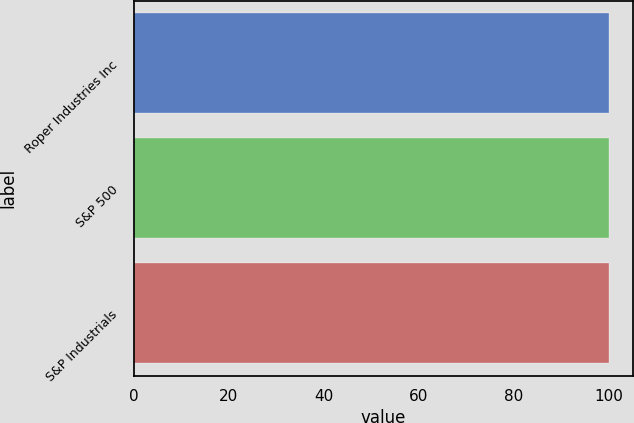<chart> <loc_0><loc_0><loc_500><loc_500><bar_chart><fcel>Roper Industries Inc<fcel>S&P 500<fcel>S&P Industrials<nl><fcel>100<fcel>100.1<fcel>100.2<nl></chart> 